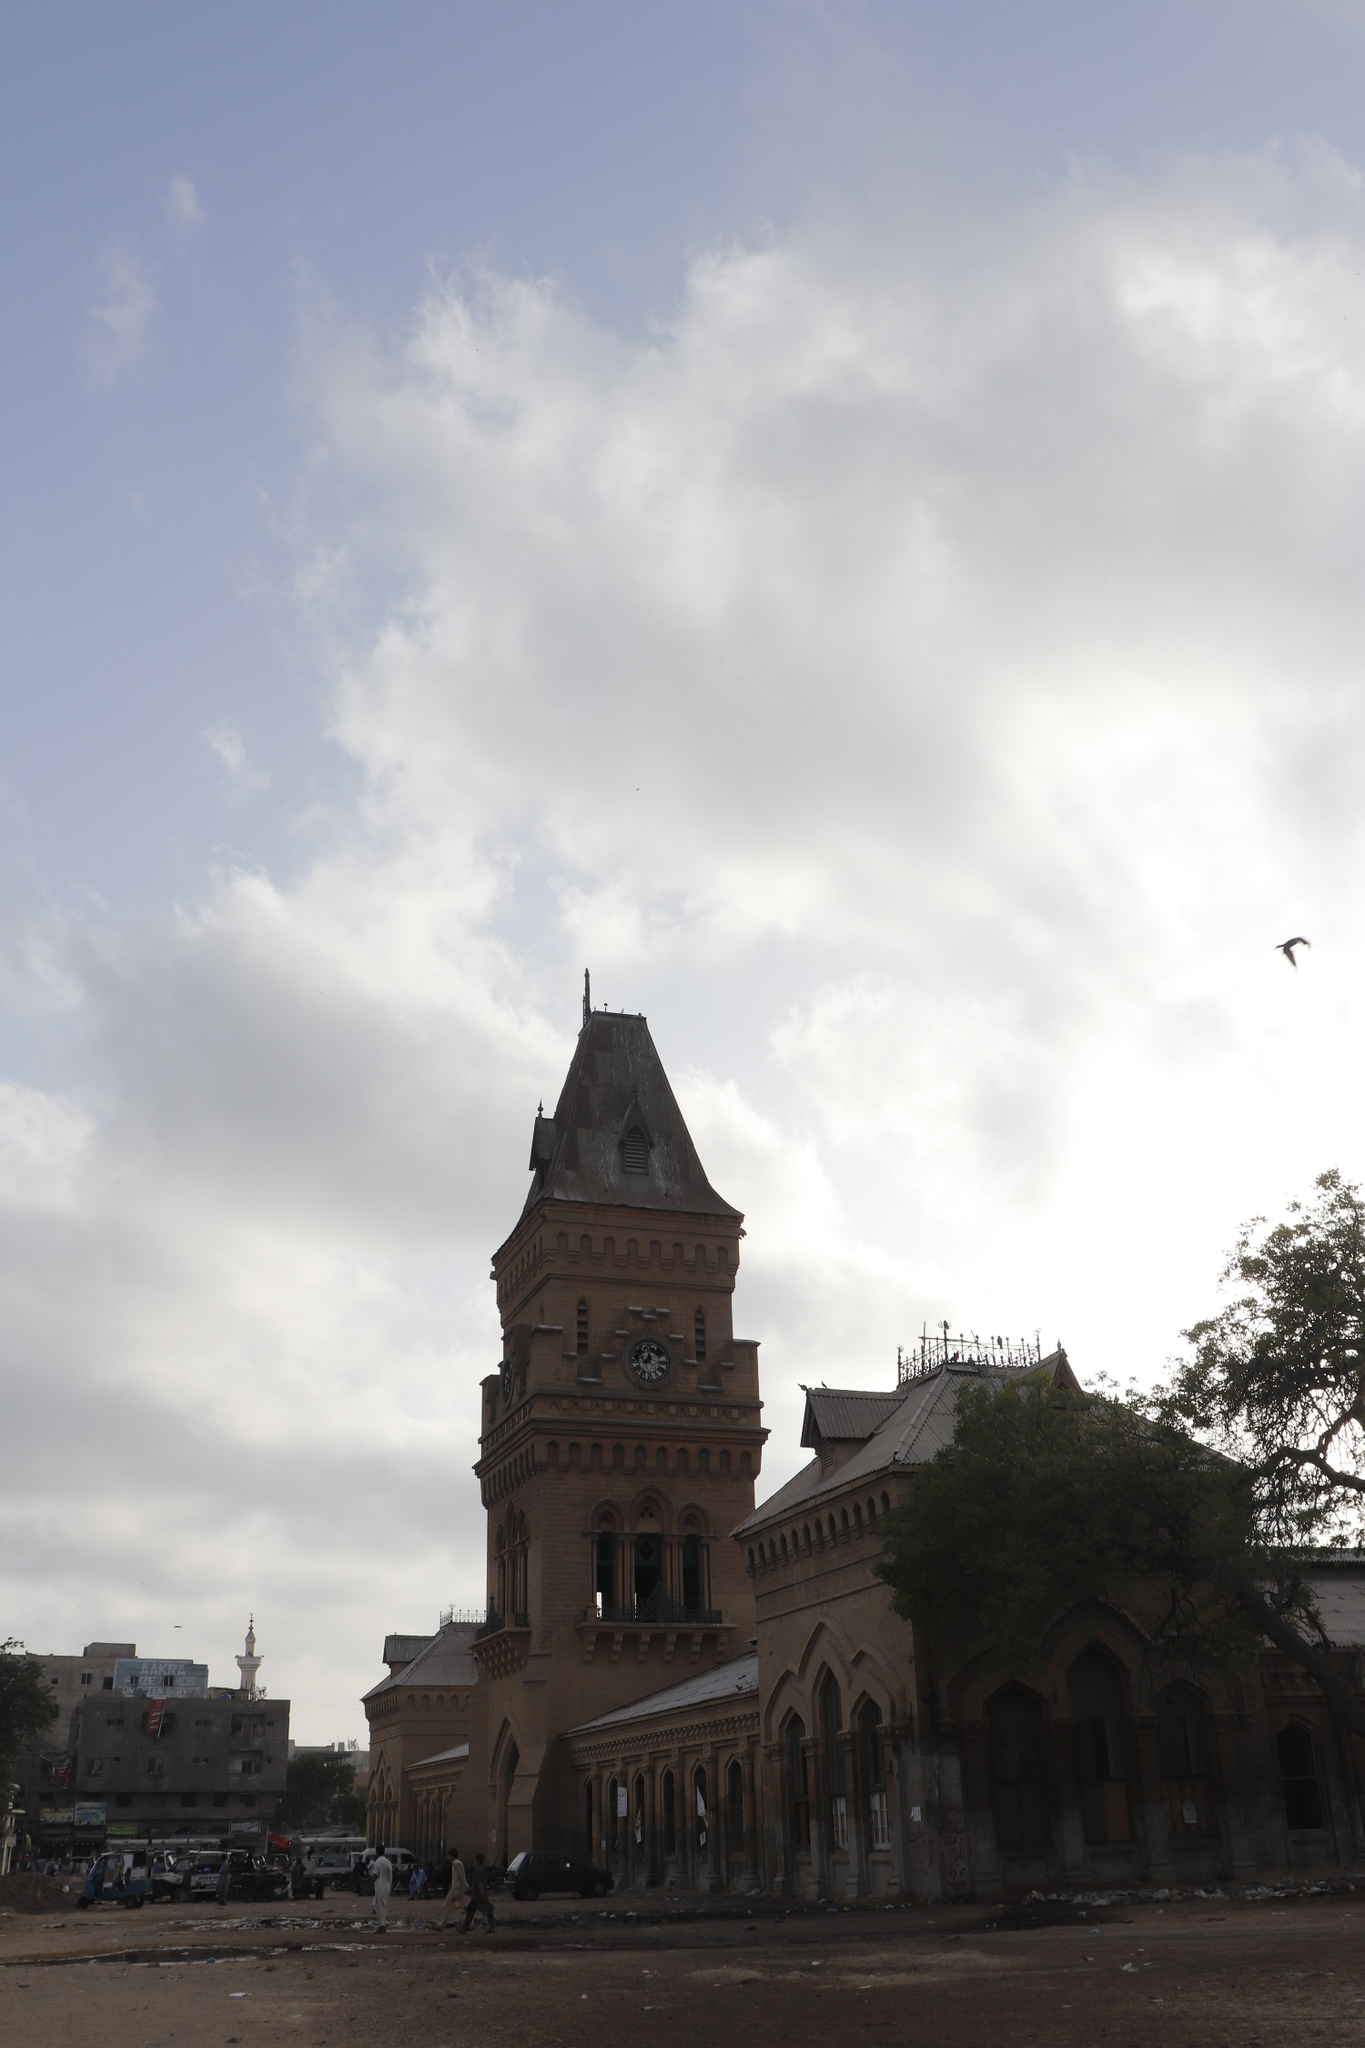What is the role of Empress Market in the daily life of Karachi's residents? The Empress Market plays a central role in the daily lives of Karachi residents. It is not only a hub for buying and selling a wide variety of goods, ranging from fresh produce and meats to household items and textiles, but also a cultural and social gathering place. Here, people from different walks of life converge, fostering a sense of community and connection. The vibrant atmosphere, filled with the sounds of haggling vendors and bustling shoppers, reflects the city's dynamic spirit. For many, the market is an integral part of daily routines, essential for their livelihoods and sustenance, and a place where the rich history of the city comes to life through the stories and traditions passed down through generations.  How would you describe the architectural style of the Empress Market? The architectural style of the Empress Market is predominantly Gothic with colonial influences. The building features a prominent clock tower with a pointed roof, intricate archways, and a balcony on the second floor, all characteristic elements of Gothic architecture. The light brown color of the building contrasted with its darker roof adds to its visual appeal. The arched windows and decorative elements reflect the design sensibilities of the British colonial period, blending functionality with artistic embellishments. This style not only adds to the market's historical charm but also stands as a testament to the architectural grandeur of the time it was built. 